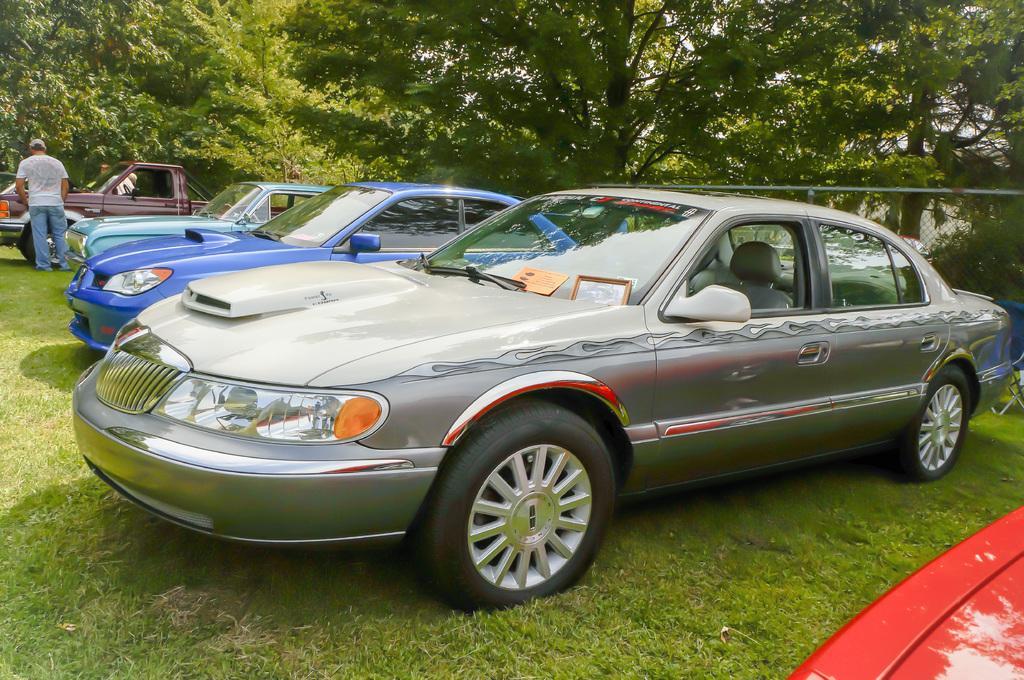Describe this image in one or two sentences. In this image there are few different colors of cars are on the grassland. A person is standing on the grassland. He is wearing a cap. Behind the vehicle there are few persons. Right side there is an object on the grassland. Background there are few trees. 